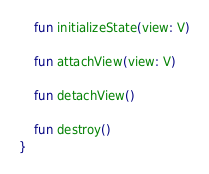Convert code to text. <code><loc_0><loc_0><loc_500><loc_500><_Kotlin_>    fun initializeState(view: V)

    fun attachView(view: V)

    fun detachView()

    fun destroy()
}</code> 